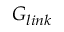Convert formula to latex. <formula><loc_0><loc_0><loc_500><loc_500>G _ { l i n k }</formula> 